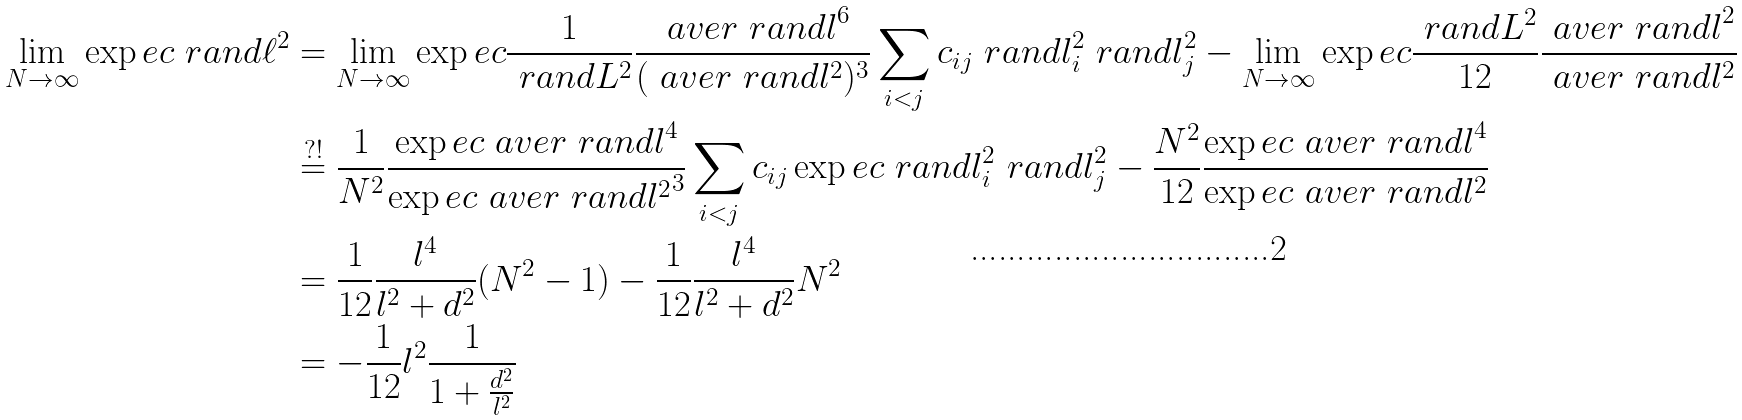Convert formula to latex. <formula><loc_0><loc_0><loc_500><loc_500>\lim _ { N \rightarrow \infty } \exp e c { \ r a n d { \ell ^ { 2 } } } & = \lim _ { N \rightarrow \infty } \exp e c { \frac { 1 } { \ r a n d { L } ^ { 2 } } \frac { \ a v e r { \ r a n d { l } } ^ { 6 } } { ( \ a v e r { \ r a n d { l } ^ { 2 } } ) ^ { 3 } } \sum _ { i < j } c _ { i j } \ r a n d { l } _ { i } ^ { 2 } \ r a n d { l } _ { j } ^ { 2 } } - \lim _ { N \rightarrow \infty } \exp e c { \frac { \ r a n d { L } ^ { 2 } } { 1 2 } \frac { \ a v e r { \ r a n d { l } } ^ { 2 } } { \ a v e r { \ r a n d { l } ^ { 2 } } } } \\ & \overset { ? ! } { = } \frac { 1 } { N ^ { 2 } } \frac { \exp e c { \ a v e r { \ r a n d { l } } } ^ { 4 } } { \exp e c { \ a v e r { \ r a n d { l } ^ { 2 } } } ^ { 3 } } \sum _ { i < j } c _ { i j } \exp e c { \ r a n d { l } _ { i } ^ { 2 } \ r a n d { l } _ { j } ^ { 2 } } - \frac { N ^ { 2 } } { 1 2 } \frac { \exp e c { \ a v e r { \ r a n d { l } } } ^ { 4 } } { \exp e c { \ a v e r { \ r a n d { l } ^ { 2 } } } } \\ & = \frac { 1 } { 1 2 } \frac { l ^ { 4 } } { l ^ { 2 } + d ^ { 2 } } ( N ^ { 2 } - 1 ) - \frac { 1 } { 1 2 } \frac { l ^ { 4 } } { l ^ { 2 } + d ^ { 2 } } N ^ { 2 } \\ & = - \frac { 1 } { 1 2 } l ^ { 2 } \frac { 1 } { 1 + \frac { d ^ { 2 } } { l ^ { 2 } } }</formula> 